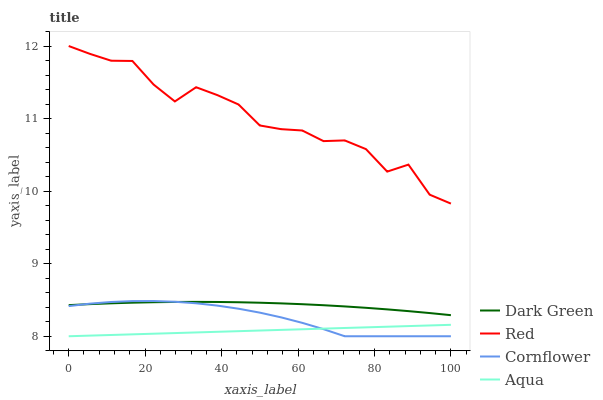Does Red have the minimum area under the curve?
Answer yes or no. No. Does Aqua have the maximum area under the curve?
Answer yes or no. No. Is Red the smoothest?
Answer yes or no. No. Is Aqua the roughest?
Answer yes or no. No. Does Red have the lowest value?
Answer yes or no. No. Does Aqua have the highest value?
Answer yes or no. No. Is Aqua less than Dark Green?
Answer yes or no. Yes. Is Red greater than Aqua?
Answer yes or no. Yes. Does Aqua intersect Dark Green?
Answer yes or no. No. 